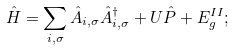Convert formula to latex. <formula><loc_0><loc_0><loc_500><loc_500>\hat { H } = \sum _ { { i } , \sigma } \hat { A } _ { { i } , \sigma } \hat { A } ^ { \dagger } _ { { i } , \sigma } + U \hat { P } + E _ { g } ^ { I I } ;</formula> 